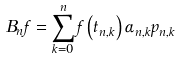Convert formula to latex. <formula><loc_0><loc_0><loc_500><loc_500>B _ { n } f = \sum _ { k = 0 } ^ { n } f \left ( t _ { n , k } \right ) \alpha _ { n , k } p _ { n , k }</formula> 